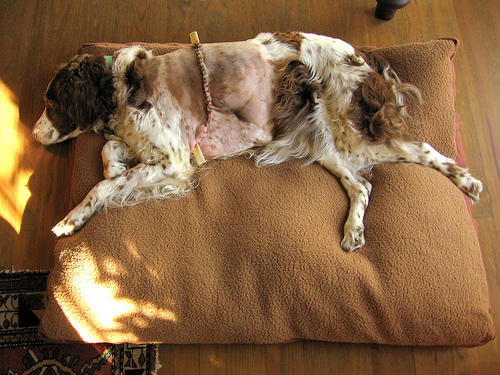<image>
Is there a floor under the dog? Yes. The floor is positioned underneath the dog, with the dog above it in the vertical space. 